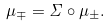<formula> <loc_0><loc_0><loc_500><loc_500>\mu _ { \mp } = \Sigma \circ \mu _ { \pm } .</formula> 